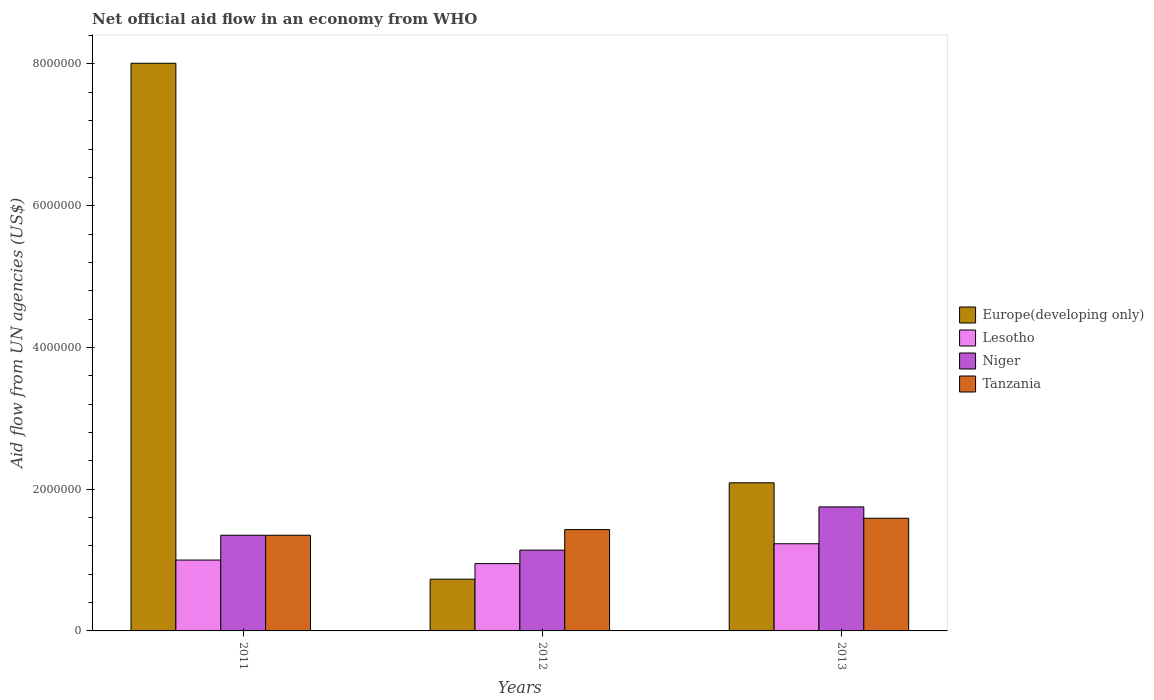How many different coloured bars are there?
Give a very brief answer. 4. How many groups of bars are there?
Your answer should be compact. 3. Are the number of bars on each tick of the X-axis equal?
Offer a terse response. Yes. How many bars are there on the 2nd tick from the left?
Keep it short and to the point. 4. How many bars are there on the 3rd tick from the right?
Keep it short and to the point. 4. What is the label of the 3rd group of bars from the left?
Make the answer very short. 2013. In how many cases, is the number of bars for a given year not equal to the number of legend labels?
Give a very brief answer. 0. What is the net official aid flow in Lesotho in 2011?
Your answer should be very brief. 1.00e+06. Across all years, what is the maximum net official aid flow in Tanzania?
Ensure brevity in your answer.  1.59e+06. Across all years, what is the minimum net official aid flow in Niger?
Provide a succinct answer. 1.14e+06. In which year was the net official aid flow in Europe(developing only) maximum?
Make the answer very short. 2011. What is the total net official aid flow in Tanzania in the graph?
Give a very brief answer. 4.37e+06. What is the difference between the net official aid flow in Tanzania in 2012 and that in 2013?
Offer a very short reply. -1.60e+05. What is the average net official aid flow in Europe(developing only) per year?
Offer a terse response. 3.61e+06. In the year 2013, what is the difference between the net official aid flow in Tanzania and net official aid flow in Niger?
Offer a terse response. -1.60e+05. In how many years, is the net official aid flow in Europe(developing only) greater than 6000000 US$?
Keep it short and to the point. 1. What is the ratio of the net official aid flow in Tanzania in 2011 to that in 2013?
Provide a succinct answer. 0.85. Is the net official aid flow in Niger in 2011 less than that in 2012?
Offer a very short reply. No. Is the difference between the net official aid flow in Tanzania in 2011 and 2012 greater than the difference between the net official aid flow in Niger in 2011 and 2012?
Your response must be concise. No. What is the difference between the highest and the lowest net official aid flow in Europe(developing only)?
Provide a succinct answer. 7.28e+06. In how many years, is the net official aid flow in Tanzania greater than the average net official aid flow in Tanzania taken over all years?
Give a very brief answer. 1. Is it the case that in every year, the sum of the net official aid flow in Tanzania and net official aid flow in Europe(developing only) is greater than the sum of net official aid flow in Niger and net official aid flow in Lesotho?
Give a very brief answer. No. What does the 2nd bar from the left in 2011 represents?
Make the answer very short. Lesotho. What does the 3rd bar from the right in 2012 represents?
Your answer should be compact. Lesotho. Is it the case that in every year, the sum of the net official aid flow in Niger and net official aid flow in Tanzania is greater than the net official aid flow in Europe(developing only)?
Ensure brevity in your answer.  No. How many years are there in the graph?
Your answer should be compact. 3. Are the values on the major ticks of Y-axis written in scientific E-notation?
Make the answer very short. No. Does the graph contain any zero values?
Your answer should be very brief. No. Does the graph contain grids?
Offer a terse response. No. Where does the legend appear in the graph?
Your response must be concise. Center right. What is the title of the graph?
Your answer should be very brief. Net official aid flow in an economy from WHO. Does "Guinea" appear as one of the legend labels in the graph?
Give a very brief answer. No. What is the label or title of the Y-axis?
Keep it short and to the point. Aid flow from UN agencies (US$). What is the Aid flow from UN agencies (US$) of Europe(developing only) in 2011?
Keep it short and to the point. 8.01e+06. What is the Aid flow from UN agencies (US$) of Niger in 2011?
Provide a succinct answer. 1.35e+06. What is the Aid flow from UN agencies (US$) in Tanzania in 2011?
Offer a terse response. 1.35e+06. What is the Aid flow from UN agencies (US$) of Europe(developing only) in 2012?
Your answer should be compact. 7.30e+05. What is the Aid flow from UN agencies (US$) in Lesotho in 2012?
Make the answer very short. 9.50e+05. What is the Aid flow from UN agencies (US$) of Niger in 2012?
Your response must be concise. 1.14e+06. What is the Aid flow from UN agencies (US$) of Tanzania in 2012?
Offer a very short reply. 1.43e+06. What is the Aid flow from UN agencies (US$) of Europe(developing only) in 2013?
Provide a short and direct response. 2.09e+06. What is the Aid flow from UN agencies (US$) in Lesotho in 2013?
Offer a terse response. 1.23e+06. What is the Aid flow from UN agencies (US$) of Niger in 2013?
Your response must be concise. 1.75e+06. What is the Aid flow from UN agencies (US$) of Tanzania in 2013?
Your answer should be compact. 1.59e+06. Across all years, what is the maximum Aid flow from UN agencies (US$) of Europe(developing only)?
Make the answer very short. 8.01e+06. Across all years, what is the maximum Aid flow from UN agencies (US$) in Lesotho?
Your answer should be very brief. 1.23e+06. Across all years, what is the maximum Aid flow from UN agencies (US$) in Niger?
Offer a very short reply. 1.75e+06. Across all years, what is the maximum Aid flow from UN agencies (US$) in Tanzania?
Keep it short and to the point. 1.59e+06. Across all years, what is the minimum Aid flow from UN agencies (US$) of Europe(developing only)?
Your answer should be compact. 7.30e+05. Across all years, what is the minimum Aid flow from UN agencies (US$) of Lesotho?
Your answer should be compact. 9.50e+05. Across all years, what is the minimum Aid flow from UN agencies (US$) of Niger?
Offer a terse response. 1.14e+06. Across all years, what is the minimum Aid flow from UN agencies (US$) in Tanzania?
Ensure brevity in your answer.  1.35e+06. What is the total Aid flow from UN agencies (US$) of Europe(developing only) in the graph?
Provide a succinct answer. 1.08e+07. What is the total Aid flow from UN agencies (US$) of Lesotho in the graph?
Ensure brevity in your answer.  3.18e+06. What is the total Aid flow from UN agencies (US$) of Niger in the graph?
Offer a terse response. 4.24e+06. What is the total Aid flow from UN agencies (US$) of Tanzania in the graph?
Offer a terse response. 4.37e+06. What is the difference between the Aid flow from UN agencies (US$) in Europe(developing only) in 2011 and that in 2012?
Ensure brevity in your answer.  7.28e+06. What is the difference between the Aid flow from UN agencies (US$) in Lesotho in 2011 and that in 2012?
Provide a short and direct response. 5.00e+04. What is the difference between the Aid flow from UN agencies (US$) of Tanzania in 2011 and that in 2012?
Offer a terse response. -8.00e+04. What is the difference between the Aid flow from UN agencies (US$) of Europe(developing only) in 2011 and that in 2013?
Provide a succinct answer. 5.92e+06. What is the difference between the Aid flow from UN agencies (US$) of Niger in 2011 and that in 2013?
Your answer should be very brief. -4.00e+05. What is the difference between the Aid flow from UN agencies (US$) in Tanzania in 2011 and that in 2013?
Offer a very short reply. -2.40e+05. What is the difference between the Aid flow from UN agencies (US$) of Europe(developing only) in 2012 and that in 2013?
Your answer should be compact. -1.36e+06. What is the difference between the Aid flow from UN agencies (US$) in Lesotho in 2012 and that in 2013?
Make the answer very short. -2.80e+05. What is the difference between the Aid flow from UN agencies (US$) of Niger in 2012 and that in 2013?
Offer a terse response. -6.10e+05. What is the difference between the Aid flow from UN agencies (US$) in Tanzania in 2012 and that in 2013?
Ensure brevity in your answer.  -1.60e+05. What is the difference between the Aid flow from UN agencies (US$) in Europe(developing only) in 2011 and the Aid flow from UN agencies (US$) in Lesotho in 2012?
Your response must be concise. 7.06e+06. What is the difference between the Aid flow from UN agencies (US$) in Europe(developing only) in 2011 and the Aid flow from UN agencies (US$) in Niger in 2012?
Give a very brief answer. 6.87e+06. What is the difference between the Aid flow from UN agencies (US$) of Europe(developing only) in 2011 and the Aid flow from UN agencies (US$) of Tanzania in 2012?
Ensure brevity in your answer.  6.58e+06. What is the difference between the Aid flow from UN agencies (US$) in Lesotho in 2011 and the Aid flow from UN agencies (US$) in Tanzania in 2012?
Your answer should be very brief. -4.30e+05. What is the difference between the Aid flow from UN agencies (US$) of Europe(developing only) in 2011 and the Aid flow from UN agencies (US$) of Lesotho in 2013?
Keep it short and to the point. 6.78e+06. What is the difference between the Aid flow from UN agencies (US$) of Europe(developing only) in 2011 and the Aid flow from UN agencies (US$) of Niger in 2013?
Give a very brief answer. 6.26e+06. What is the difference between the Aid flow from UN agencies (US$) of Europe(developing only) in 2011 and the Aid flow from UN agencies (US$) of Tanzania in 2013?
Make the answer very short. 6.42e+06. What is the difference between the Aid flow from UN agencies (US$) of Lesotho in 2011 and the Aid flow from UN agencies (US$) of Niger in 2013?
Provide a short and direct response. -7.50e+05. What is the difference between the Aid flow from UN agencies (US$) of Lesotho in 2011 and the Aid flow from UN agencies (US$) of Tanzania in 2013?
Keep it short and to the point. -5.90e+05. What is the difference between the Aid flow from UN agencies (US$) of Europe(developing only) in 2012 and the Aid flow from UN agencies (US$) of Lesotho in 2013?
Your answer should be very brief. -5.00e+05. What is the difference between the Aid flow from UN agencies (US$) of Europe(developing only) in 2012 and the Aid flow from UN agencies (US$) of Niger in 2013?
Keep it short and to the point. -1.02e+06. What is the difference between the Aid flow from UN agencies (US$) of Europe(developing only) in 2012 and the Aid flow from UN agencies (US$) of Tanzania in 2013?
Offer a terse response. -8.60e+05. What is the difference between the Aid flow from UN agencies (US$) of Lesotho in 2012 and the Aid flow from UN agencies (US$) of Niger in 2013?
Your response must be concise. -8.00e+05. What is the difference between the Aid flow from UN agencies (US$) of Lesotho in 2012 and the Aid flow from UN agencies (US$) of Tanzania in 2013?
Provide a short and direct response. -6.40e+05. What is the difference between the Aid flow from UN agencies (US$) of Niger in 2012 and the Aid flow from UN agencies (US$) of Tanzania in 2013?
Provide a short and direct response. -4.50e+05. What is the average Aid flow from UN agencies (US$) in Europe(developing only) per year?
Make the answer very short. 3.61e+06. What is the average Aid flow from UN agencies (US$) of Lesotho per year?
Give a very brief answer. 1.06e+06. What is the average Aid flow from UN agencies (US$) of Niger per year?
Make the answer very short. 1.41e+06. What is the average Aid flow from UN agencies (US$) of Tanzania per year?
Keep it short and to the point. 1.46e+06. In the year 2011, what is the difference between the Aid flow from UN agencies (US$) of Europe(developing only) and Aid flow from UN agencies (US$) of Lesotho?
Ensure brevity in your answer.  7.01e+06. In the year 2011, what is the difference between the Aid flow from UN agencies (US$) of Europe(developing only) and Aid flow from UN agencies (US$) of Niger?
Your response must be concise. 6.66e+06. In the year 2011, what is the difference between the Aid flow from UN agencies (US$) of Europe(developing only) and Aid flow from UN agencies (US$) of Tanzania?
Provide a succinct answer. 6.66e+06. In the year 2011, what is the difference between the Aid flow from UN agencies (US$) of Lesotho and Aid flow from UN agencies (US$) of Niger?
Offer a terse response. -3.50e+05. In the year 2011, what is the difference between the Aid flow from UN agencies (US$) in Lesotho and Aid flow from UN agencies (US$) in Tanzania?
Offer a very short reply. -3.50e+05. In the year 2012, what is the difference between the Aid flow from UN agencies (US$) of Europe(developing only) and Aid flow from UN agencies (US$) of Lesotho?
Offer a terse response. -2.20e+05. In the year 2012, what is the difference between the Aid flow from UN agencies (US$) in Europe(developing only) and Aid flow from UN agencies (US$) in Niger?
Provide a succinct answer. -4.10e+05. In the year 2012, what is the difference between the Aid flow from UN agencies (US$) in Europe(developing only) and Aid flow from UN agencies (US$) in Tanzania?
Make the answer very short. -7.00e+05. In the year 2012, what is the difference between the Aid flow from UN agencies (US$) of Lesotho and Aid flow from UN agencies (US$) of Niger?
Provide a succinct answer. -1.90e+05. In the year 2012, what is the difference between the Aid flow from UN agencies (US$) of Lesotho and Aid flow from UN agencies (US$) of Tanzania?
Your answer should be very brief. -4.80e+05. In the year 2013, what is the difference between the Aid flow from UN agencies (US$) of Europe(developing only) and Aid flow from UN agencies (US$) of Lesotho?
Your answer should be very brief. 8.60e+05. In the year 2013, what is the difference between the Aid flow from UN agencies (US$) in Europe(developing only) and Aid flow from UN agencies (US$) in Niger?
Offer a very short reply. 3.40e+05. In the year 2013, what is the difference between the Aid flow from UN agencies (US$) of Lesotho and Aid flow from UN agencies (US$) of Niger?
Keep it short and to the point. -5.20e+05. In the year 2013, what is the difference between the Aid flow from UN agencies (US$) in Lesotho and Aid flow from UN agencies (US$) in Tanzania?
Offer a very short reply. -3.60e+05. What is the ratio of the Aid flow from UN agencies (US$) of Europe(developing only) in 2011 to that in 2012?
Your answer should be very brief. 10.97. What is the ratio of the Aid flow from UN agencies (US$) in Lesotho in 2011 to that in 2012?
Ensure brevity in your answer.  1.05. What is the ratio of the Aid flow from UN agencies (US$) in Niger in 2011 to that in 2012?
Your answer should be very brief. 1.18. What is the ratio of the Aid flow from UN agencies (US$) of Tanzania in 2011 to that in 2012?
Provide a short and direct response. 0.94. What is the ratio of the Aid flow from UN agencies (US$) of Europe(developing only) in 2011 to that in 2013?
Your answer should be very brief. 3.83. What is the ratio of the Aid flow from UN agencies (US$) of Lesotho in 2011 to that in 2013?
Your answer should be compact. 0.81. What is the ratio of the Aid flow from UN agencies (US$) in Niger in 2011 to that in 2013?
Your answer should be compact. 0.77. What is the ratio of the Aid flow from UN agencies (US$) of Tanzania in 2011 to that in 2013?
Your response must be concise. 0.85. What is the ratio of the Aid flow from UN agencies (US$) of Europe(developing only) in 2012 to that in 2013?
Give a very brief answer. 0.35. What is the ratio of the Aid flow from UN agencies (US$) of Lesotho in 2012 to that in 2013?
Your answer should be compact. 0.77. What is the ratio of the Aid flow from UN agencies (US$) of Niger in 2012 to that in 2013?
Offer a very short reply. 0.65. What is the ratio of the Aid flow from UN agencies (US$) in Tanzania in 2012 to that in 2013?
Provide a succinct answer. 0.9. What is the difference between the highest and the second highest Aid flow from UN agencies (US$) of Europe(developing only)?
Your response must be concise. 5.92e+06. What is the difference between the highest and the second highest Aid flow from UN agencies (US$) in Niger?
Your answer should be compact. 4.00e+05. What is the difference between the highest and the lowest Aid flow from UN agencies (US$) in Europe(developing only)?
Provide a succinct answer. 7.28e+06. 